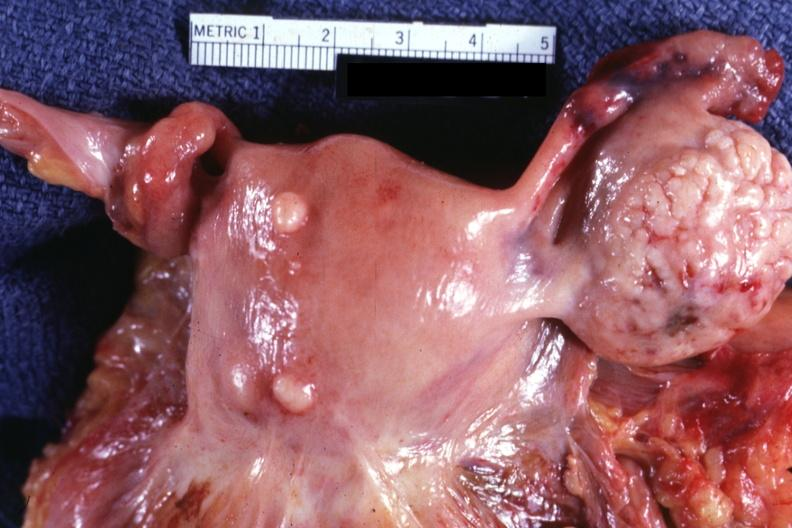what are intramural one lesion is in photo?
Answer the question using a single word or phrase. Intramural 